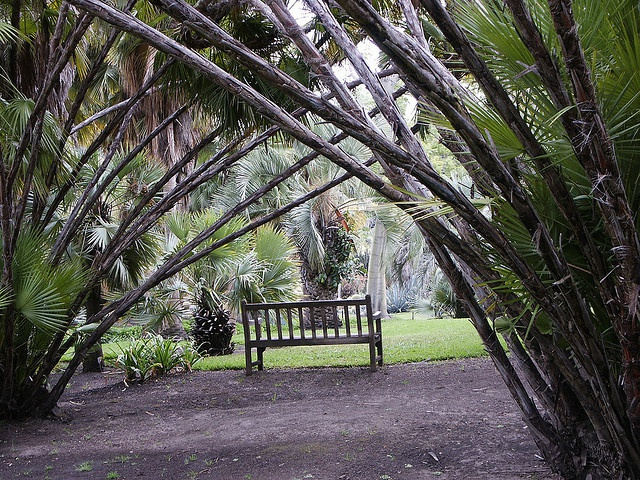Describe the objects in this image and their specific colors. I can see a bench in black, gray, darkgray, and lightgray tones in this image. 